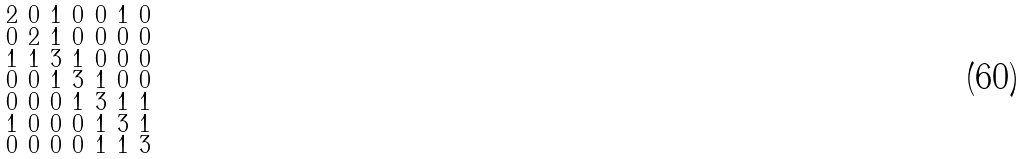Convert formula to latex. <formula><loc_0><loc_0><loc_500><loc_500>\begin{smallmatrix} 2 & 0 & 1 & 0 & 0 & 1 & 0 \\ 0 & 2 & 1 & 0 & 0 & 0 & 0 \\ 1 & 1 & 3 & 1 & 0 & 0 & 0 \\ 0 & 0 & 1 & 3 & 1 & 0 & 0 \\ 0 & 0 & 0 & 1 & 3 & 1 & 1 \\ 1 & 0 & 0 & 0 & 1 & 3 & 1 \\ 0 & 0 & 0 & 0 & 1 & 1 & 3 \end{smallmatrix}</formula> 